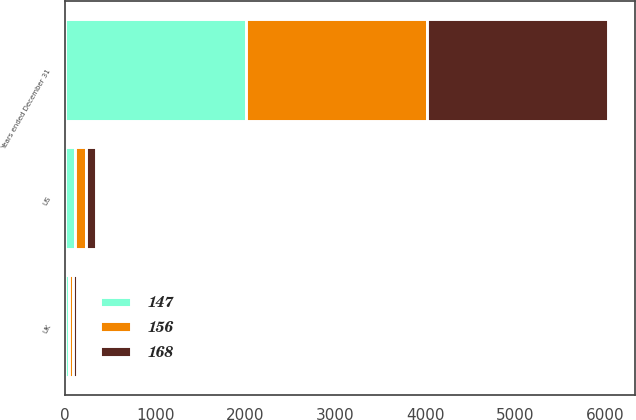<chart> <loc_0><loc_0><loc_500><loc_500><stacked_bar_chart><ecel><fcel>Years ended December 31<fcel>US<fcel>UK<nl><fcel>156<fcel>2013<fcel>123<fcel>45<nl><fcel>168<fcel>2012<fcel>115<fcel>41<nl><fcel>147<fcel>2011<fcel>104<fcel>43<nl></chart> 